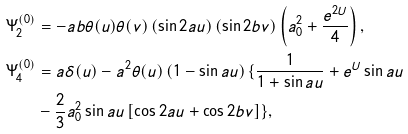<formula> <loc_0><loc_0><loc_500><loc_500>\Psi _ { 2 } ^ { ( 0 ) } & = - a b \theta ( u ) \theta ( v ) \left ( \sin 2 a u \right ) \left ( \sin 2 b v \right ) \left ( a _ { 0 } ^ { 2 } + \frac { e ^ { 2 U } } { 4 } \right ) , \\ \Psi _ { 4 } ^ { ( 0 ) } & = a \delta ( u ) - a ^ { 2 } \theta ( u ) \left ( 1 - \sin a u \right ) \{ \frac { 1 } { 1 + \sin a u } + e ^ { U } \sin a u \\ & - \frac { 2 } { 3 } a _ { 0 } ^ { 2 } \sin a u \left [ \cos 2 a u + \cos 2 b v \right ] \} ,</formula> 